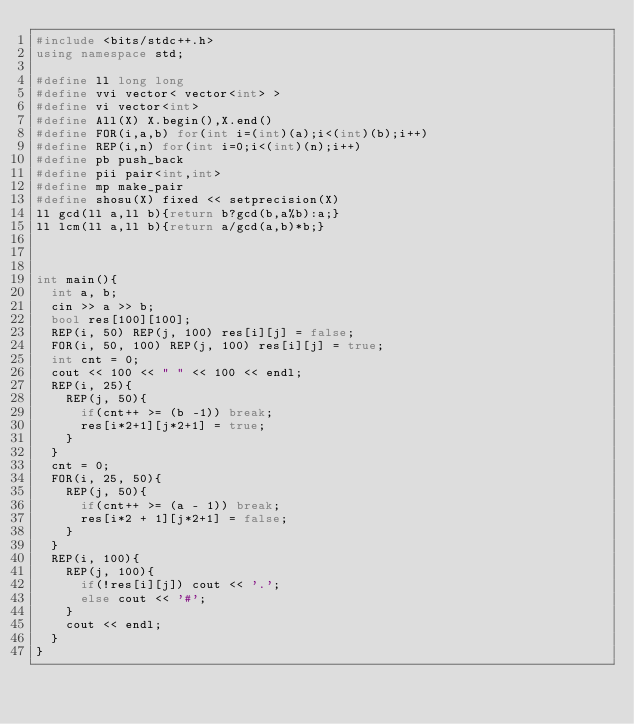<code> <loc_0><loc_0><loc_500><loc_500><_C++_>#include <bits/stdc++.h>
using namespace std;
 
#define ll long long
#define vvi vector< vector<int> >
#define vi vector<int>
#define All(X) X.begin(),X.end()
#define FOR(i,a,b) for(int i=(int)(a);i<(int)(b);i++)
#define REP(i,n) for(int i=0;i<(int)(n);i++)
#define pb push_back
#define pii pair<int,int>
#define mp make_pair
#define shosu(X) fixed << setprecision(X)
ll gcd(ll a,ll b){return b?gcd(b,a%b):a;}
ll lcm(ll a,ll b){return a/gcd(a,b)*b;}



int main(){
  int a, b;
  cin >> a >> b;
  bool res[100][100];
  REP(i, 50) REP(j, 100) res[i][j] = false;
  FOR(i, 50, 100) REP(j, 100) res[i][j] = true;
  int cnt = 0;
  cout << 100 << " " << 100 << endl;
  REP(i, 25){
    REP(j, 50){
      if(cnt++ >= (b -1)) break;
      res[i*2+1][j*2+1] = true;
    }
  }
  cnt = 0;
  FOR(i, 25, 50){
    REP(j, 50){
      if(cnt++ >= (a - 1)) break;
      res[i*2 + 1][j*2+1] = false;
    }
  }
  REP(i, 100){
    REP(j, 100){
      if(!res[i][j]) cout << '.';
      else cout << '#';
    }
    cout << endl;
  }
} 	
</code> 